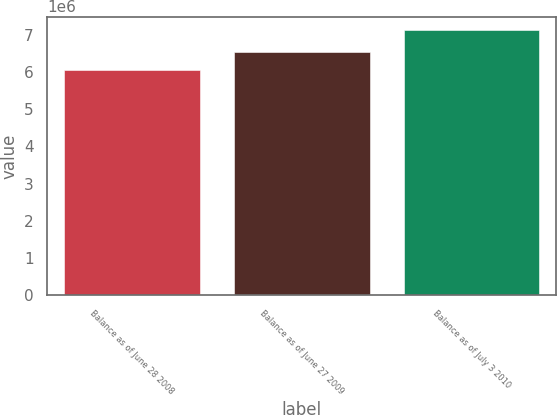<chart> <loc_0><loc_0><loc_500><loc_500><bar_chart><fcel>Balance as of June 28 2008<fcel>Balance as of June 27 2009<fcel>Balance as of July 3 2010<nl><fcel>6.04143e+06<fcel>6.53989e+06<fcel>7.13414e+06<nl></chart> 